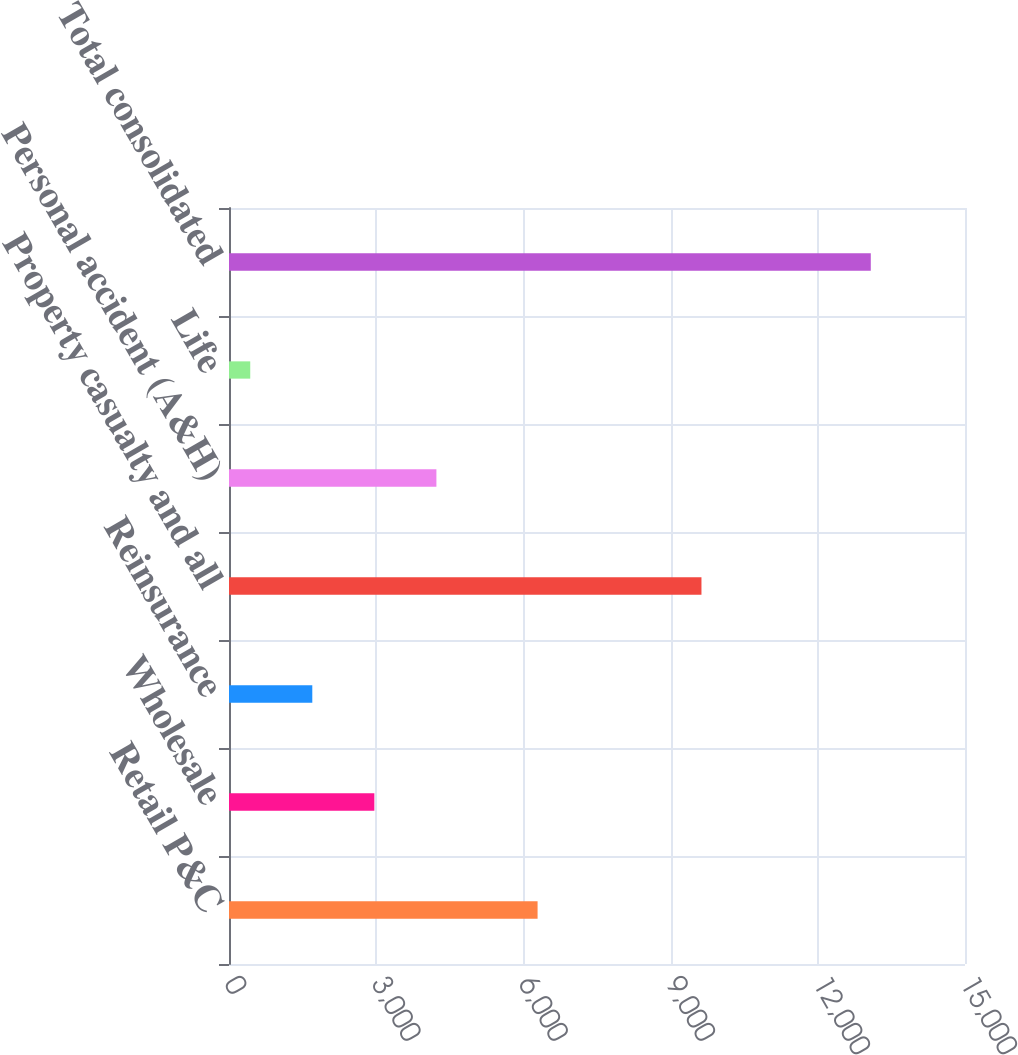<chart> <loc_0><loc_0><loc_500><loc_500><bar_chart><fcel>Retail P&C<fcel>Wholesale<fcel>Reinsurance<fcel>Property casualty and all<fcel>Personal accident (A&H)<fcel>Life<fcel>Total consolidated<nl><fcel>6289<fcel>2962.4<fcel>1697.7<fcel>9629<fcel>4227.1<fcel>433<fcel>13080<nl></chart> 